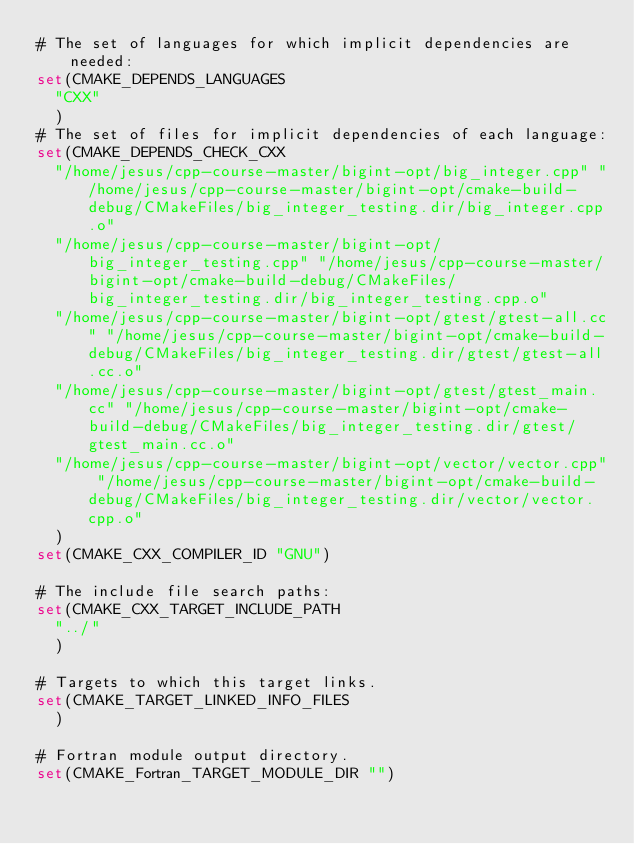<code> <loc_0><loc_0><loc_500><loc_500><_CMake_># The set of languages for which implicit dependencies are needed:
set(CMAKE_DEPENDS_LANGUAGES
  "CXX"
  )
# The set of files for implicit dependencies of each language:
set(CMAKE_DEPENDS_CHECK_CXX
  "/home/jesus/cpp-course-master/bigint-opt/big_integer.cpp" "/home/jesus/cpp-course-master/bigint-opt/cmake-build-debug/CMakeFiles/big_integer_testing.dir/big_integer.cpp.o"
  "/home/jesus/cpp-course-master/bigint-opt/big_integer_testing.cpp" "/home/jesus/cpp-course-master/bigint-opt/cmake-build-debug/CMakeFiles/big_integer_testing.dir/big_integer_testing.cpp.o"
  "/home/jesus/cpp-course-master/bigint-opt/gtest/gtest-all.cc" "/home/jesus/cpp-course-master/bigint-opt/cmake-build-debug/CMakeFiles/big_integer_testing.dir/gtest/gtest-all.cc.o"
  "/home/jesus/cpp-course-master/bigint-opt/gtest/gtest_main.cc" "/home/jesus/cpp-course-master/bigint-opt/cmake-build-debug/CMakeFiles/big_integer_testing.dir/gtest/gtest_main.cc.o"
  "/home/jesus/cpp-course-master/bigint-opt/vector/vector.cpp" "/home/jesus/cpp-course-master/bigint-opt/cmake-build-debug/CMakeFiles/big_integer_testing.dir/vector/vector.cpp.o"
  )
set(CMAKE_CXX_COMPILER_ID "GNU")

# The include file search paths:
set(CMAKE_CXX_TARGET_INCLUDE_PATH
  "../"
  )

# Targets to which this target links.
set(CMAKE_TARGET_LINKED_INFO_FILES
  )

# Fortran module output directory.
set(CMAKE_Fortran_TARGET_MODULE_DIR "")
</code> 